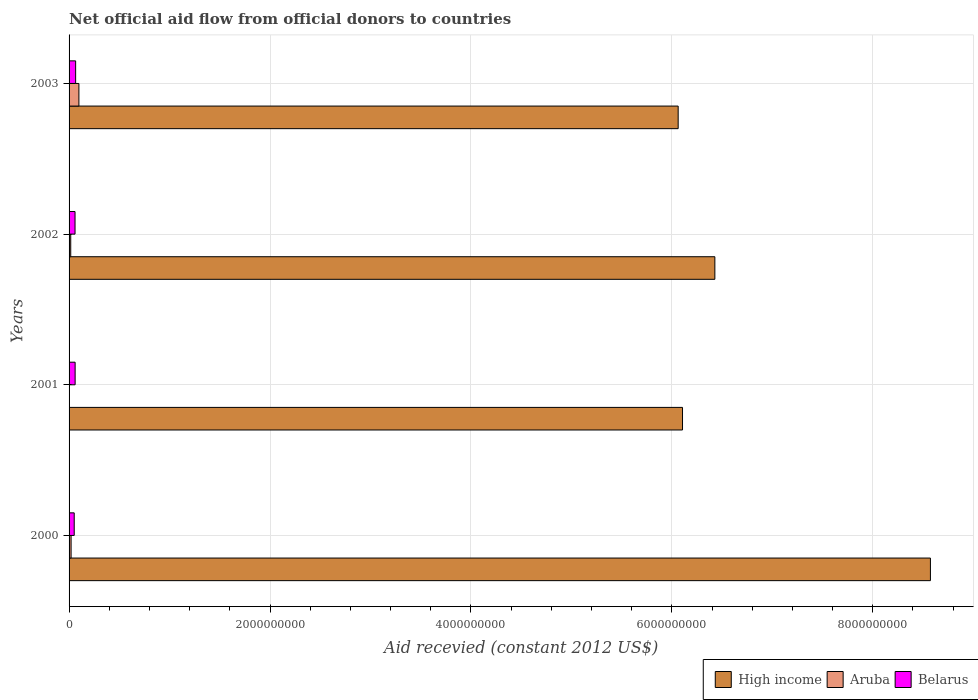How many different coloured bars are there?
Your response must be concise. 3. How many groups of bars are there?
Offer a very short reply. 4. Are the number of bars on each tick of the Y-axis equal?
Provide a succinct answer. No. How many bars are there on the 2nd tick from the top?
Ensure brevity in your answer.  3. In how many cases, is the number of bars for a given year not equal to the number of legend labels?
Keep it short and to the point. 1. What is the total aid received in High income in 2002?
Your response must be concise. 6.43e+09. Across all years, what is the maximum total aid received in High income?
Your response must be concise. 8.57e+09. Across all years, what is the minimum total aid received in Belarus?
Your answer should be very brief. 5.12e+07. What is the total total aid received in High income in the graph?
Offer a terse response. 2.72e+1. What is the difference between the total aid received in Belarus in 2001 and that in 2003?
Your response must be concise. -5.04e+06. What is the difference between the total aid received in Aruba in 2000 and the total aid received in Belarus in 2001?
Provide a short and direct response. -4.02e+07. What is the average total aid received in Belarus per year?
Provide a short and direct response. 5.90e+07. In the year 2000, what is the difference between the total aid received in Belarus and total aid received in Aruba?
Offer a very short reply. 3.11e+07. What is the ratio of the total aid received in High income in 2001 to that in 2003?
Ensure brevity in your answer.  1.01. Is the total aid received in High income in 2001 less than that in 2002?
Provide a short and direct response. Yes. What is the difference between the highest and the second highest total aid received in High income?
Ensure brevity in your answer.  2.15e+09. What is the difference between the highest and the lowest total aid received in Aruba?
Make the answer very short. 9.79e+07. In how many years, is the total aid received in Aruba greater than the average total aid received in Aruba taken over all years?
Keep it short and to the point. 1. How many bars are there?
Make the answer very short. 11. Are all the bars in the graph horizontal?
Your answer should be compact. Yes. How many years are there in the graph?
Provide a succinct answer. 4. Are the values on the major ticks of X-axis written in scientific E-notation?
Provide a short and direct response. No. Does the graph contain any zero values?
Your response must be concise. Yes. Where does the legend appear in the graph?
Give a very brief answer. Bottom right. How many legend labels are there?
Your answer should be compact. 3. How are the legend labels stacked?
Your answer should be compact. Horizontal. What is the title of the graph?
Make the answer very short. Net official aid flow from official donors to countries. What is the label or title of the X-axis?
Give a very brief answer. Aid recevied (constant 2012 US$). What is the label or title of the Y-axis?
Your answer should be compact. Years. What is the Aid recevied (constant 2012 US$) of High income in 2000?
Make the answer very short. 8.57e+09. What is the Aid recevied (constant 2012 US$) in Aruba in 2000?
Your response must be concise. 2.01e+07. What is the Aid recevied (constant 2012 US$) of Belarus in 2000?
Ensure brevity in your answer.  5.12e+07. What is the Aid recevied (constant 2012 US$) of High income in 2001?
Your answer should be very brief. 6.11e+09. What is the Aid recevied (constant 2012 US$) in Belarus in 2001?
Offer a very short reply. 6.03e+07. What is the Aid recevied (constant 2012 US$) of High income in 2002?
Give a very brief answer. 6.43e+09. What is the Aid recevied (constant 2012 US$) in Aruba in 2002?
Your response must be concise. 1.65e+07. What is the Aid recevied (constant 2012 US$) of Belarus in 2002?
Keep it short and to the point. 5.93e+07. What is the Aid recevied (constant 2012 US$) of High income in 2003?
Offer a terse response. 6.06e+09. What is the Aid recevied (constant 2012 US$) in Aruba in 2003?
Provide a succinct answer. 9.79e+07. What is the Aid recevied (constant 2012 US$) of Belarus in 2003?
Offer a terse response. 6.53e+07. Across all years, what is the maximum Aid recevied (constant 2012 US$) in High income?
Make the answer very short. 8.57e+09. Across all years, what is the maximum Aid recevied (constant 2012 US$) in Aruba?
Give a very brief answer. 9.79e+07. Across all years, what is the maximum Aid recevied (constant 2012 US$) in Belarus?
Provide a short and direct response. 6.53e+07. Across all years, what is the minimum Aid recevied (constant 2012 US$) of High income?
Offer a terse response. 6.06e+09. Across all years, what is the minimum Aid recevied (constant 2012 US$) of Belarus?
Make the answer very short. 5.12e+07. What is the total Aid recevied (constant 2012 US$) of High income in the graph?
Provide a short and direct response. 2.72e+1. What is the total Aid recevied (constant 2012 US$) in Aruba in the graph?
Offer a very short reply. 1.35e+08. What is the total Aid recevied (constant 2012 US$) in Belarus in the graph?
Your answer should be very brief. 2.36e+08. What is the difference between the Aid recevied (constant 2012 US$) in High income in 2000 and that in 2001?
Ensure brevity in your answer.  2.47e+09. What is the difference between the Aid recevied (constant 2012 US$) in Belarus in 2000 and that in 2001?
Keep it short and to the point. -9.04e+06. What is the difference between the Aid recevied (constant 2012 US$) of High income in 2000 and that in 2002?
Your response must be concise. 2.15e+09. What is the difference between the Aid recevied (constant 2012 US$) of Aruba in 2000 and that in 2002?
Ensure brevity in your answer.  3.62e+06. What is the difference between the Aid recevied (constant 2012 US$) of Belarus in 2000 and that in 2002?
Offer a terse response. -8.02e+06. What is the difference between the Aid recevied (constant 2012 US$) in High income in 2000 and that in 2003?
Your answer should be compact. 2.51e+09. What is the difference between the Aid recevied (constant 2012 US$) of Aruba in 2000 and that in 2003?
Your answer should be very brief. -7.78e+07. What is the difference between the Aid recevied (constant 2012 US$) of Belarus in 2000 and that in 2003?
Provide a short and direct response. -1.41e+07. What is the difference between the Aid recevied (constant 2012 US$) in High income in 2001 and that in 2002?
Keep it short and to the point. -3.22e+08. What is the difference between the Aid recevied (constant 2012 US$) of Belarus in 2001 and that in 2002?
Keep it short and to the point. 1.02e+06. What is the difference between the Aid recevied (constant 2012 US$) in High income in 2001 and that in 2003?
Offer a very short reply. 4.32e+07. What is the difference between the Aid recevied (constant 2012 US$) in Belarus in 2001 and that in 2003?
Offer a terse response. -5.04e+06. What is the difference between the Aid recevied (constant 2012 US$) in High income in 2002 and that in 2003?
Keep it short and to the point. 3.65e+08. What is the difference between the Aid recevied (constant 2012 US$) of Aruba in 2002 and that in 2003?
Provide a short and direct response. -8.14e+07. What is the difference between the Aid recevied (constant 2012 US$) of Belarus in 2002 and that in 2003?
Make the answer very short. -6.06e+06. What is the difference between the Aid recevied (constant 2012 US$) of High income in 2000 and the Aid recevied (constant 2012 US$) of Belarus in 2001?
Give a very brief answer. 8.51e+09. What is the difference between the Aid recevied (constant 2012 US$) in Aruba in 2000 and the Aid recevied (constant 2012 US$) in Belarus in 2001?
Your response must be concise. -4.02e+07. What is the difference between the Aid recevied (constant 2012 US$) in High income in 2000 and the Aid recevied (constant 2012 US$) in Aruba in 2002?
Ensure brevity in your answer.  8.56e+09. What is the difference between the Aid recevied (constant 2012 US$) of High income in 2000 and the Aid recevied (constant 2012 US$) of Belarus in 2002?
Make the answer very short. 8.51e+09. What is the difference between the Aid recevied (constant 2012 US$) in Aruba in 2000 and the Aid recevied (constant 2012 US$) in Belarus in 2002?
Keep it short and to the point. -3.91e+07. What is the difference between the Aid recevied (constant 2012 US$) of High income in 2000 and the Aid recevied (constant 2012 US$) of Aruba in 2003?
Your answer should be compact. 8.48e+09. What is the difference between the Aid recevied (constant 2012 US$) of High income in 2000 and the Aid recevied (constant 2012 US$) of Belarus in 2003?
Offer a very short reply. 8.51e+09. What is the difference between the Aid recevied (constant 2012 US$) in Aruba in 2000 and the Aid recevied (constant 2012 US$) in Belarus in 2003?
Give a very brief answer. -4.52e+07. What is the difference between the Aid recevied (constant 2012 US$) of High income in 2001 and the Aid recevied (constant 2012 US$) of Aruba in 2002?
Your response must be concise. 6.09e+09. What is the difference between the Aid recevied (constant 2012 US$) in High income in 2001 and the Aid recevied (constant 2012 US$) in Belarus in 2002?
Keep it short and to the point. 6.05e+09. What is the difference between the Aid recevied (constant 2012 US$) of High income in 2001 and the Aid recevied (constant 2012 US$) of Aruba in 2003?
Your answer should be very brief. 6.01e+09. What is the difference between the Aid recevied (constant 2012 US$) in High income in 2001 and the Aid recevied (constant 2012 US$) in Belarus in 2003?
Provide a succinct answer. 6.04e+09. What is the difference between the Aid recevied (constant 2012 US$) in High income in 2002 and the Aid recevied (constant 2012 US$) in Aruba in 2003?
Ensure brevity in your answer.  6.33e+09. What is the difference between the Aid recevied (constant 2012 US$) in High income in 2002 and the Aid recevied (constant 2012 US$) in Belarus in 2003?
Your response must be concise. 6.36e+09. What is the difference between the Aid recevied (constant 2012 US$) of Aruba in 2002 and the Aid recevied (constant 2012 US$) of Belarus in 2003?
Offer a terse response. -4.88e+07. What is the average Aid recevied (constant 2012 US$) in High income per year?
Your answer should be compact. 6.79e+09. What is the average Aid recevied (constant 2012 US$) in Aruba per year?
Your answer should be very brief. 3.36e+07. What is the average Aid recevied (constant 2012 US$) in Belarus per year?
Offer a very short reply. 5.90e+07. In the year 2000, what is the difference between the Aid recevied (constant 2012 US$) of High income and Aid recevied (constant 2012 US$) of Aruba?
Provide a succinct answer. 8.55e+09. In the year 2000, what is the difference between the Aid recevied (constant 2012 US$) of High income and Aid recevied (constant 2012 US$) of Belarus?
Make the answer very short. 8.52e+09. In the year 2000, what is the difference between the Aid recevied (constant 2012 US$) of Aruba and Aid recevied (constant 2012 US$) of Belarus?
Your answer should be compact. -3.11e+07. In the year 2001, what is the difference between the Aid recevied (constant 2012 US$) of High income and Aid recevied (constant 2012 US$) of Belarus?
Your answer should be compact. 6.05e+09. In the year 2002, what is the difference between the Aid recevied (constant 2012 US$) of High income and Aid recevied (constant 2012 US$) of Aruba?
Ensure brevity in your answer.  6.41e+09. In the year 2002, what is the difference between the Aid recevied (constant 2012 US$) in High income and Aid recevied (constant 2012 US$) in Belarus?
Your answer should be very brief. 6.37e+09. In the year 2002, what is the difference between the Aid recevied (constant 2012 US$) in Aruba and Aid recevied (constant 2012 US$) in Belarus?
Your answer should be compact. -4.28e+07. In the year 2003, what is the difference between the Aid recevied (constant 2012 US$) of High income and Aid recevied (constant 2012 US$) of Aruba?
Your answer should be very brief. 5.96e+09. In the year 2003, what is the difference between the Aid recevied (constant 2012 US$) of High income and Aid recevied (constant 2012 US$) of Belarus?
Provide a short and direct response. 6.00e+09. In the year 2003, what is the difference between the Aid recevied (constant 2012 US$) in Aruba and Aid recevied (constant 2012 US$) in Belarus?
Offer a terse response. 3.26e+07. What is the ratio of the Aid recevied (constant 2012 US$) in High income in 2000 to that in 2001?
Offer a very short reply. 1.4. What is the ratio of the Aid recevied (constant 2012 US$) of Belarus in 2000 to that in 2001?
Make the answer very short. 0.85. What is the ratio of the Aid recevied (constant 2012 US$) of High income in 2000 to that in 2002?
Your answer should be compact. 1.33. What is the ratio of the Aid recevied (constant 2012 US$) in Aruba in 2000 to that in 2002?
Make the answer very short. 1.22. What is the ratio of the Aid recevied (constant 2012 US$) in Belarus in 2000 to that in 2002?
Give a very brief answer. 0.86. What is the ratio of the Aid recevied (constant 2012 US$) in High income in 2000 to that in 2003?
Your response must be concise. 1.41. What is the ratio of the Aid recevied (constant 2012 US$) of Aruba in 2000 to that in 2003?
Offer a terse response. 0.21. What is the ratio of the Aid recevied (constant 2012 US$) of Belarus in 2000 to that in 2003?
Ensure brevity in your answer.  0.78. What is the ratio of the Aid recevied (constant 2012 US$) in High income in 2001 to that in 2002?
Offer a terse response. 0.95. What is the ratio of the Aid recevied (constant 2012 US$) of Belarus in 2001 to that in 2002?
Give a very brief answer. 1.02. What is the ratio of the Aid recevied (constant 2012 US$) in High income in 2001 to that in 2003?
Your response must be concise. 1.01. What is the ratio of the Aid recevied (constant 2012 US$) in Belarus in 2001 to that in 2003?
Offer a terse response. 0.92. What is the ratio of the Aid recevied (constant 2012 US$) of High income in 2002 to that in 2003?
Ensure brevity in your answer.  1.06. What is the ratio of the Aid recevied (constant 2012 US$) of Aruba in 2002 to that in 2003?
Keep it short and to the point. 0.17. What is the ratio of the Aid recevied (constant 2012 US$) in Belarus in 2002 to that in 2003?
Give a very brief answer. 0.91. What is the difference between the highest and the second highest Aid recevied (constant 2012 US$) of High income?
Make the answer very short. 2.15e+09. What is the difference between the highest and the second highest Aid recevied (constant 2012 US$) in Aruba?
Ensure brevity in your answer.  7.78e+07. What is the difference between the highest and the second highest Aid recevied (constant 2012 US$) in Belarus?
Offer a terse response. 5.04e+06. What is the difference between the highest and the lowest Aid recevied (constant 2012 US$) in High income?
Your response must be concise. 2.51e+09. What is the difference between the highest and the lowest Aid recevied (constant 2012 US$) in Aruba?
Provide a succinct answer. 9.79e+07. What is the difference between the highest and the lowest Aid recevied (constant 2012 US$) in Belarus?
Your response must be concise. 1.41e+07. 